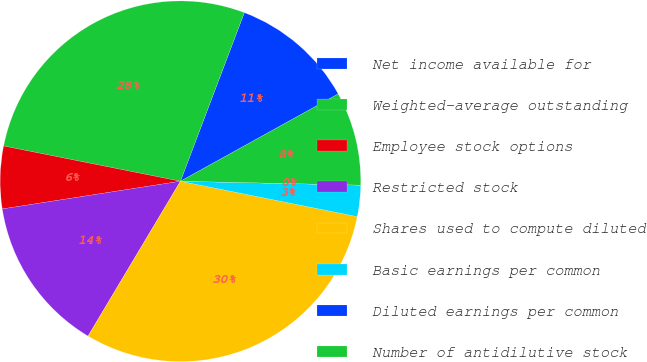Convert chart to OTSL. <chart><loc_0><loc_0><loc_500><loc_500><pie_chart><fcel>Net income available for<fcel>Weighted-average outstanding<fcel>Employee stock options<fcel>Restricted stock<fcel>Shares used to compute diluted<fcel>Basic earnings per common<fcel>Diluted earnings per common<fcel>Number of antidilutive stock<nl><fcel>11.19%<fcel>27.63%<fcel>5.59%<fcel>13.98%<fcel>30.42%<fcel>2.8%<fcel>0.0%<fcel>8.39%<nl></chart> 